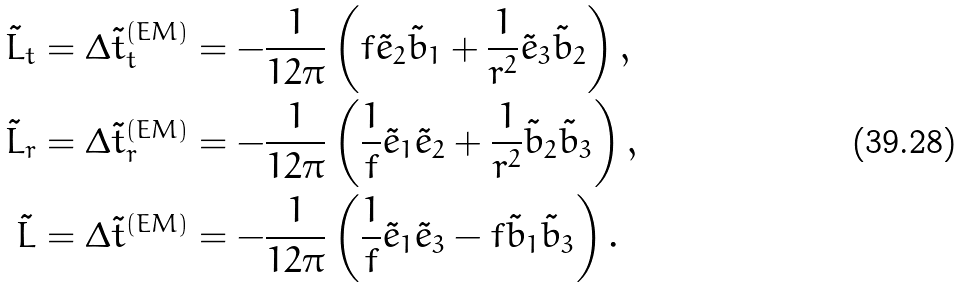<formula> <loc_0><loc_0><loc_500><loc_500>\tilde { L } _ { t } & = \Delta \tilde { t } _ { t } ^ { ( E M ) } = - \frac { 1 } { 1 2 \pi } \left ( f \tilde { e } _ { 2 } \tilde { b } _ { 1 } + \frac { 1 } { r ^ { 2 } } \tilde { e } _ { 3 } \tilde { b } _ { 2 } \right ) , \\ \tilde { L } _ { r } & = \Delta \tilde { t } _ { r } ^ { ( E M ) } = - \frac { 1 } { 1 2 \pi } \left ( \frac { 1 } { f } \tilde { e } _ { 1 } \tilde { e } _ { 2 } + \frac { 1 } { r ^ { 2 } } \tilde { b } _ { 2 } \tilde { b } _ { 3 } \right ) , \\ \tilde { L } & = \Delta \tilde { t } ^ { ( E M ) } = - \frac { 1 } { 1 2 \pi } \left ( \frac { 1 } { f } \tilde { e } _ { 1 } \tilde { e } _ { 3 } - f \tilde { b } _ { 1 } \tilde { b } _ { 3 } \right ) .</formula> 